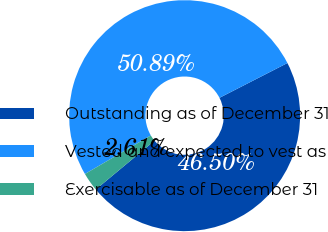<chart> <loc_0><loc_0><loc_500><loc_500><pie_chart><fcel>Outstanding as of December 31<fcel>Vested and expected to vest as<fcel>Exercisable as of December 31<nl><fcel>46.5%<fcel>50.89%<fcel>2.61%<nl></chart> 